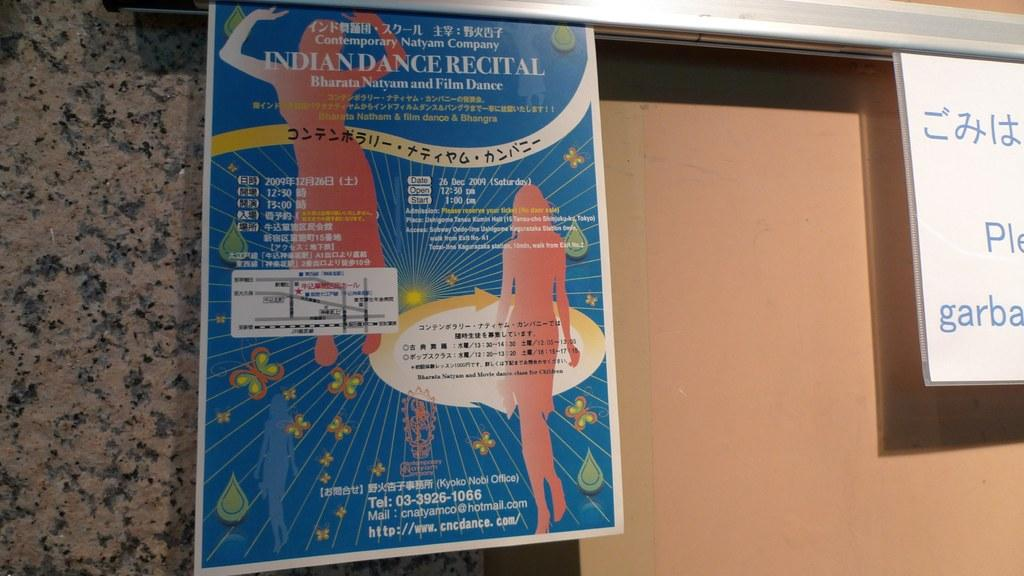<image>
Render a clear and concise summary of the photo. A poster advertising the Indian Dance Recital is attached to a wall. 